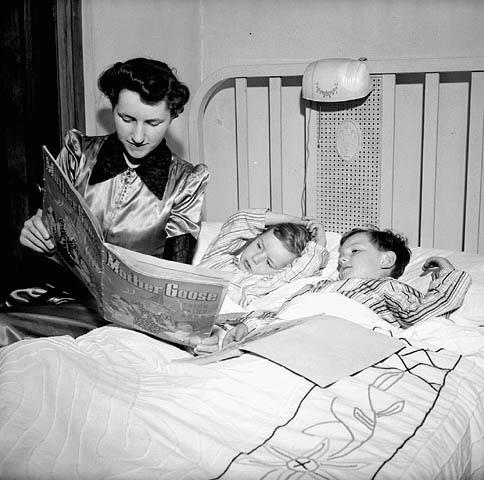Why is this book appropriate for her to read? Please explain your reasoning. nursery rhymes. There are toddlers in bed. 